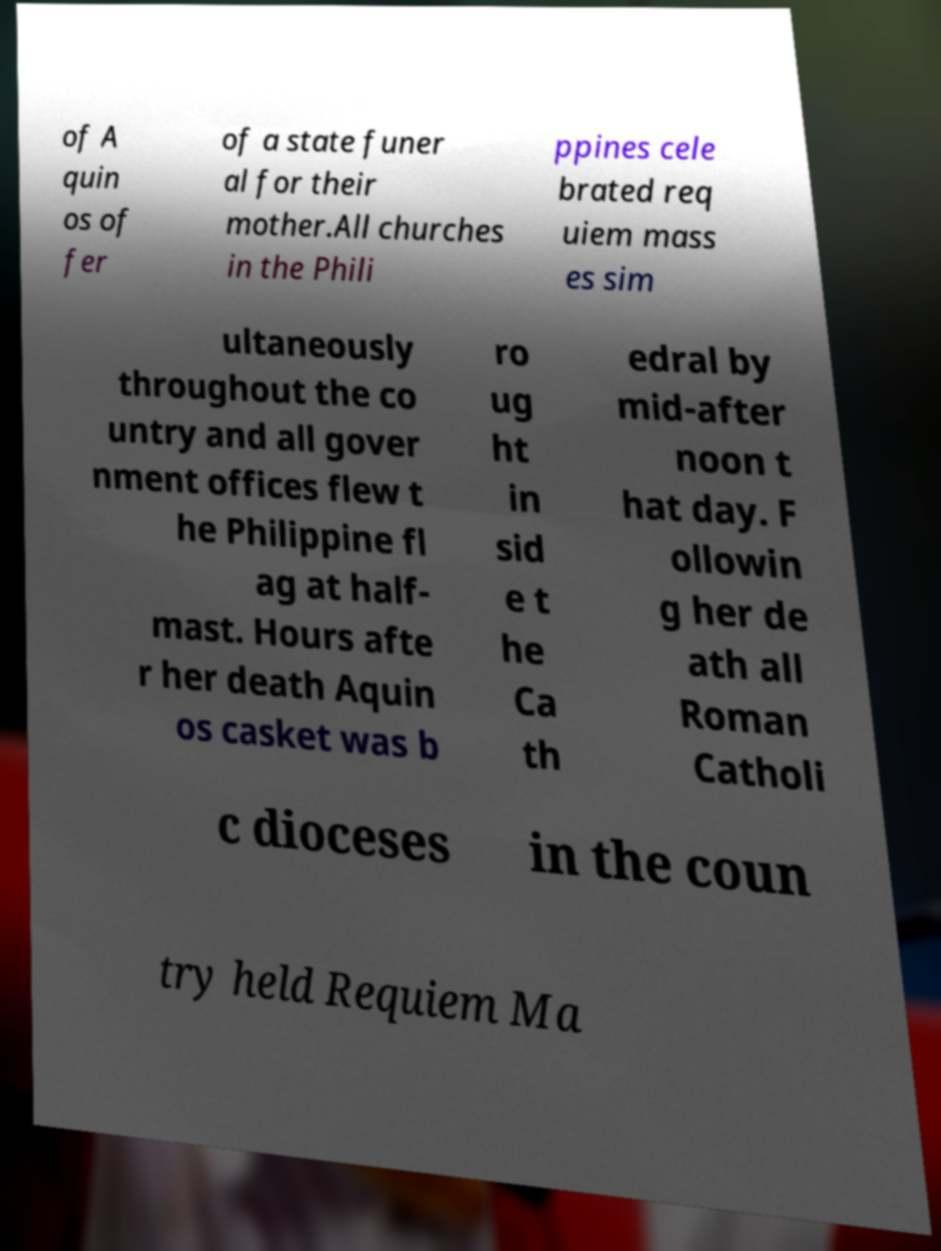Can you accurately transcribe the text from the provided image for me? of A quin os of fer of a state funer al for their mother.All churches in the Phili ppines cele brated req uiem mass es sim ultaneously throughout the co untry and all gover nment offices flew t he Philippine fl ag at half- mast. Hours afte r her death Aquin os casket was b ro ug ht in sid e t he Ca th edral by mid-after noon t hat day. F ollowin g her de ath all Roman Catholi c dioceses in the coun try held Requiem Ma 